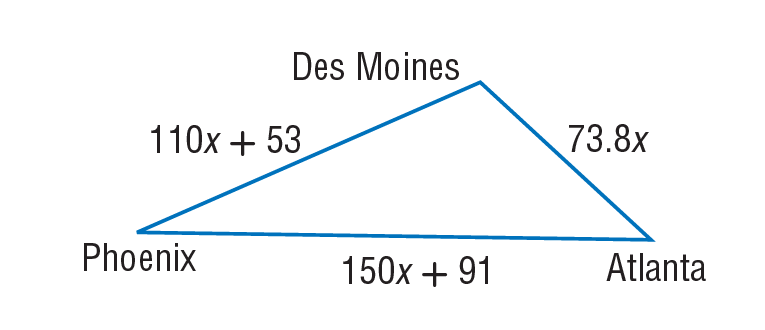Answer the mathemtical geometry problem and directly provide the correct option letter.
Question: A plane travels from Des Moines to Phoenix, on to Atlanta, and back to Des Moines, as shown below. Find the distance in miles from Atlanta to Des Moines if the total trip was 3482 miles.
Choices: A: 73.8 B: 110 C: 150 D: 738 D 